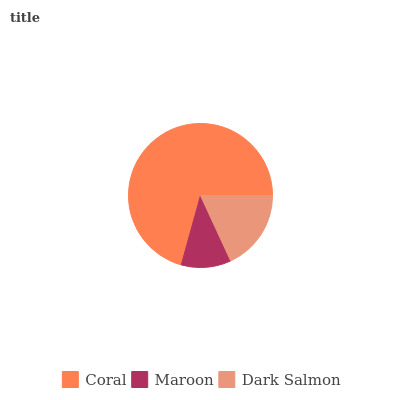Is Maroon the minimum?
Answer yes or no. Yes. Is Coral the maximum?
Answer yes or no. Yes. Is Dark Salmon the minimum?
Answer yes or no. No. Is Dark Salmon the maximum?
Answer yes or no. No. Is Dark Salmon greater than Maroon?
Answer yes or no. Yes. Is Maroon less than Dark Salmon?
Answer yes or no. Yes. Is Maroon greater than Dark Salmon?
Answer yes or no. No. Is Dark Salmon less than Maroon?
Answer yes or no. No. Is Dark Salmon the high median?
Answer yes or no. Yes. Is Dark Salmon the low median?
Answer yes or no. Yes. Is Maroon the high median?
Answer yes or no. No. Is Maroon the low median?
Answer yes or no. No. 